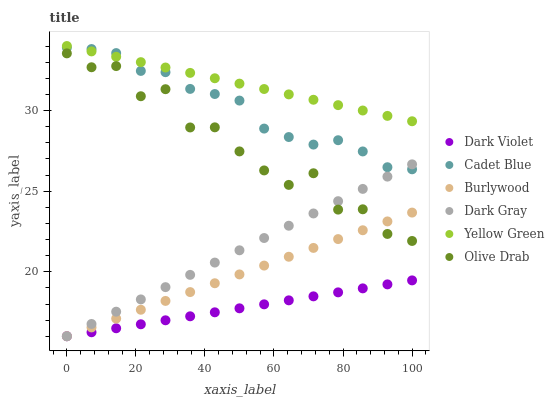Does Dark Violet have the minimum area under the curve?
Answer yes or no. Yes. Does Yellow Green have the maximum area under the curve?
Answer yes or no. Yes. Does Burlywood have the minimum area under the curve?
Answer yes or no. No. Does Burlywood have the maximum area under the curve?
Answer yes or no. No. Is Burlywood the smoothest?
Answer yes or no. Yes. Is Olive Drab the roughest?
Answer yes or no. Yes. Is Yellow Green the smoothest?
Answer yes or no. No. Is Yellow Green the roughest?
Answer yes or no. No. Does Burlywood have the lowest value?
Answer yes or no. Yes. Does Yellow Green have the lowest value?
Answer yes or no. No. Does Yellow Green have the highest value?
Answer yes or no. Yes. Does Burlywood have the highest value?
Answer yes or no. No. Is Dark Violet less than Yellow Green?
Answer yes or no. Yes. Is Cadet Blue greater than Burlywood?
Answer yes or no. Yes. Does Burlywood intersect Olive Drab?
Answer yes or no. Yes. Is Burlywood less than Olive Drab?
Answer yes or no. No. Is Burlywood greater than Olive Drab?
Answer yes or no. No. Does Dark Violet intersect Yellow Green?
Answer yes or no. No. 